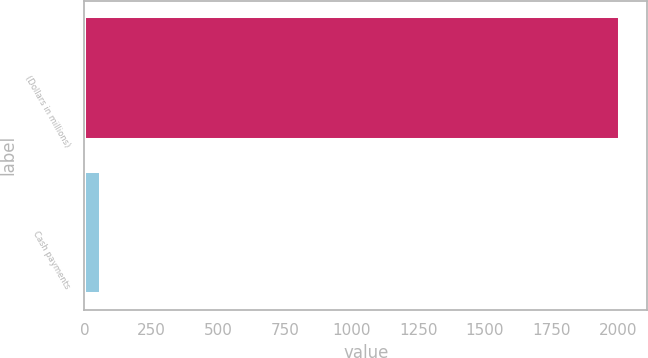<chart> <loc_0><loc_0><loc_500><loc_500><bar_chart><fcel>(Dollars in millions)<fcel>Cash payments<nl><fcel>2007<fcel>61<nl></chart> 